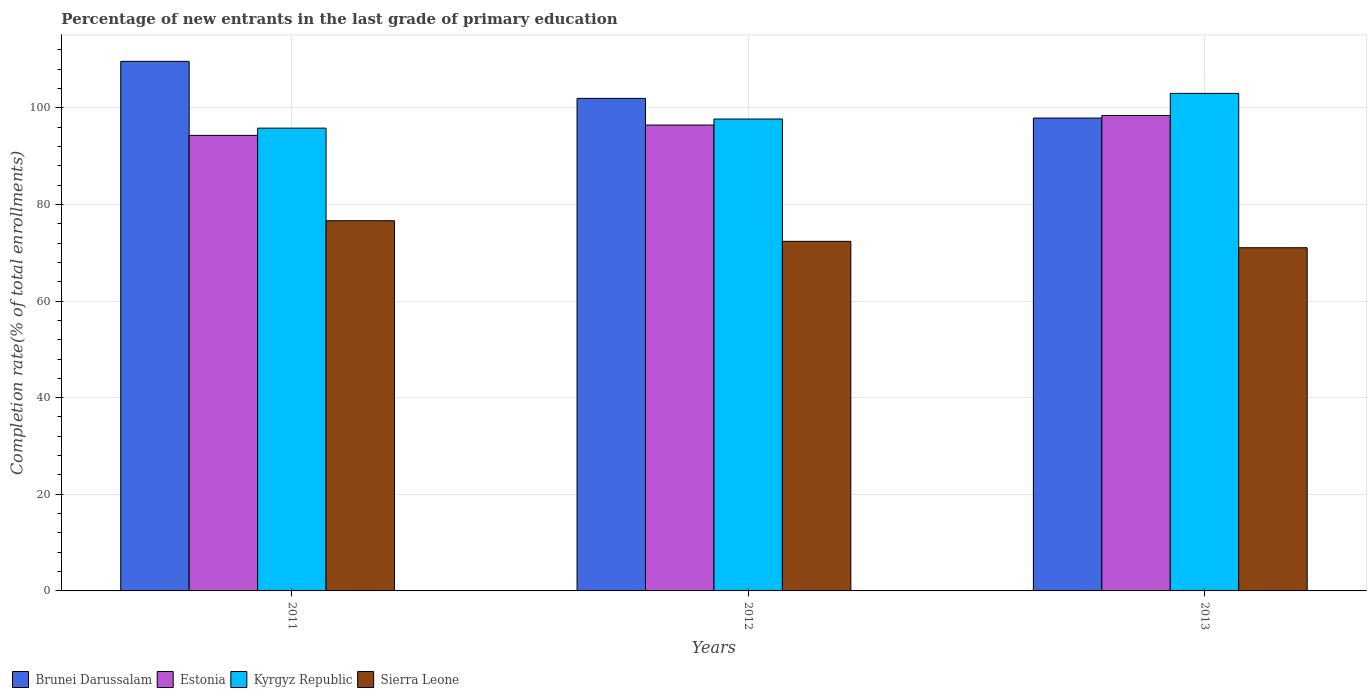Are the number of bars per tick equal to the number of legend labels?
Your answer should be very brief. Yes. Are the number of bars on each tick of the X-axis equal?
Make the answer very short. Yes. How many bars are there on the 2nd tick from the left?
Offer a very short reply. 4. What is the label of the 3rd group of bars from the left?
Your response must be concise. 2013. In how many cases, is the number of bars for a given year not equal to the number of legend labels?
Ensure brevity in your answer.  0. What is the percentage of new entrants in Kyrgyz Republic in 2011?
Give a very brief answer. 95.78. Across all years, what is the maximum percentage of new entrants in Sierra Leone?
Offer a very short reply. 76.62. Across all years, what is the minimum percentage of new entrants in Brunei Darussalam?
Offer a terse response. 97.87. In which year was the percentage of new entrants in Kyrgyz Republic maximum?
Offer a terse response. 2013. In which year was the percentage of new entrants in Sierra Leone minimum?
Offer a terse response. 2013. What is the total percentage of new entrants in Sierra Leone in the graph?
Offer a terse response. 220.01. What is the difference between the percentage of new entrants in Sierra Leone in 2012 and that in 2013?
Your response must be concise. 1.33. What is the difference between the percentage of new entrants in Sierra Leone in 2011 and the percentage of new entrants in Brunei Darussalam in 2012?
Your answer should be very brief. -25.32. What is the average percentage of new entrants in Estonia per year?
Your answer should be very brief. 96.37. In the year 2012, what is the difference between the percentage of new entrants in Estonia and percentage of new entrants in Kyrgyz Republic?
Provide a short and direct response. -1.25. What is the ratio of the percentage of new entrants in Estonia in 2012 to that in 2013?
Provide a short and direct response. 0.98. What is the difference between the highest and the second highest percentage of new entrants in Sierra Leone?
Offer a terse response. 4.27. What is the difference between the highest and the lowest percentage of new entrants in Brunei Darussalam?
Offer a terse response. 11.74. Is it the case that in every year, the sum of the percentage of new entrants in Brunei Darussalam and percentage of new entrants in Kyrgyz Republic is greater than the sum of percentage of new entrants in Estonia and percentage of new entrants in Sierra Leone?
Your answer should be compact. No. What does the 4th bar from the left in 2012 represents?
Provide a short and direct response. Sierra Leone. What does the 2nd bar from the right in 2011 represents?
Offer a terse response. Kyrgyz Republic. Is it the case that in every year, the sum of the percentage of new entrants in Estonia and percentage of new entrants in Brunei Darussalam is greater than the percentage of new entrants in Kyrgyz Republic?
Make the answer very short. Yes. Are all the bars in the graph horizontal?
Offer a very short reply. No. How are the legend labels stacked?
Your answer should be compact. Horizontal. What is the title of the graph?
Provide a succinct answer. Percentage of new entrants in the last grade of primary education. Does "Albania" appear as one of the legend labels in the graph?
Make the answer very short. No. What is the label or title of the X-axis?
Your answer should be very brief. Years. What is the label or title of the Y-axis?
Provide a short and direct response. Completion rate(% of total enrollments). What is the Completion rate(% of total enrollments) in Brunei Darussalam in 2011?
Your answer should be compact. 109.61. What is the Completion rate(% of total enrollments) in Estonia in 2011?
Give a very brief answer. 94.29. What is the Completion rate(% of total enrollments) of Kyrgyz Republic in 2011?
Ensure brevity in your answer.  95.78. What is the Completion rate(% of total enrollments) in Sierra Leone in 2011?
Your answer should be compact. 76.62. What is the Completion rate(% of total enrollments) in Brunei Darussalam in 2012?
Ensure brevity in your answer.  101.94. What is the Completion rate(% of total enrollments) in Estonia in 2012?
Give a very brief answer. 96.42. What is the Completion rate(% of total enrollments) in Kyrgyz Republic in 2012?
Provide a short and direct response. 97.67. What is the Completion rate(% of total enrollments) in Sierra Leone in 2012?
Make the answer very short. 72.36. What is the Completion rate(% of total enrollments) of Brunei Darussalam in 2013?
Offer a very short reply. 97.87. What is the Completion rate(% of total enrollments) in Estonia in 2013?
Your answer should be compact. 98.4. What is the Completion rate(% of total enrollments) in Kyrgyz Republic in 2013?
Give a very brief answer. 102.98. What is the Completion rate(% of total enrollments) in Sierra Leone in 2013?
Your response must be concise. 71.03. Across all years, what is the maximum Completion rate(% of total enrollments) in Brunei Darussalam?
Provide a short and direct response. 109.61. Across all years, what is the maximum Completion rate(% of total enrollments) of Estonia?
Your response must be concise. 98.4. Across all years, what is the maximum Completion rate(% of total enrollments) of Kyrgyz Republic?
Provide a short and direct response. 102.98. Across all years, what is the maximum Completion rate(% of total enrollments) in Sierra Leone?
Your response must be concise. 76.62. Across all years, what is the minimum Completion rate(% of total enrollments) in Brunei Darussalam?
Your answer should be very brief. 97.87. Across all years, what is the minimum Completion rate(% of total enrollments) in Estonia?
Make the answer very short. 94.29. Across all years, what is the minimum Completion rate(% of total enrollments) of Kyrgyz Republic?
Keep it short and to the point. 95.78. Across all years, what is the minimum Completion rate(% of total enrollments) in Sierra Leone?
Ensure brevity in your answer.  71.03. What is the total Completion rate(% of total enrollments) of Brunei Darussalam in the graph?
Offer a very short reply. 309.42. What is the total Completion rate(% of total enrollments) in Estonia in the graph?
Give a very brief answer. 289.1. What is the total Completion rate(% of total enrollments) in Kyrgyz Republic in the graph?
Your answer should be compact. 296.43. What is the total Completion rate(% of total enrollments) in Sierra Leone in the graph?
Provide a short and direct response. 220.01. What is the difference between the Completion rate(% of total enrollments) of Brunei Darussalam in 2011 and that in 2012?
Your response must be concise. 7.66. What is the difference between the Completion rate(% of total enrollments) of Estonia in 2011 and that in 2012?
Provide a short and direct response. -2.14. What is the difference between the Completion rate(% of total enrollments) in Kyrgyz Republic in 2011 and that in 2012?
Make the answer very short. -1.89. What is the difference between the Completion rate(% of total enrollments) of Sierra Leone in 2011 and that in 2012?
Provide a short and direct response. 4.27. What is the difference between the Completion rate(% of total enrollments) of Brunei Darussalam in 2011 and that in 2013?
Make the answer very short. 11.74. What is the difference between the Completion rate(% of total enrollments) in Estonia in 2011 and that in 2013?
Provide a short and direct response. -4.11. What is the difference between the Completion rate(% of total enrollments) of Kyrgyz Republic in 2011 and that in 2013?
Provide a succinct answer. -7.19. What is the difference between the Completion rate(% of total enrollments) of Sierra Leone in 2011 and that in 2013?
Offer a very short reply. 5.59. What is the difference between the Completion rate(% of total enrollments) in Brunei Darussalam in 2012 and that in 2013?
Your answer should be very brief. 4.07. What is the difference between the Completion rate(% of total enrollments) of Estonia in 2012 and that in 2013?
Give a very brief answer. -1.98. What is the difference between the Completion rate(% of total enrollments) of Kyrgyz Republic in 2012 and that in 2013?
Provide a short and direct response. -5.31. What is the difference between the Completion rate(% of total enrollments) of Sierra Leone in 2012 and that in 2013?
Provide a succinct answer. 1.33. What is the difference between the Completion rate(% of total enrollments) of Brunei Darussalam in 2011 and the Completion rate(% of total enrollments) of Estonia in 2012?
Provide a short and direct response. 13.19. What is the difference between the Completion rate(% of total enrollments) in Brunei Darussalam in 2011 and the Completion rate(% of total enrollments) in Kyrgyz Republic in 2012?
Provide a short and direct response. 11.94. What is the difference between the Completion rate(% of total enrollments) in Brunei Darussalam in 2011 and the Completion rate(% of total enrollments) in Sierra Leone in 2012?
Keep it short and to the point. 37.25. What is the difference between the Completion rate(% of total enrollments) in Estonia in 2011 and the Completion rate(% of total enrollments) in Kyrgyz Republic in 2012?
Ensure brevity in your answer.  -3.38. What is the difference between the Completion rate(% of total enrollments) in Estonia in 2011 and the Completion rate(% of total enrollments) in Sierra Leone in 2012?
Your answer should be very brief. 21.93. What is the difference between the Completion rate(% of total enrollments) of Kyrgyz Republic in 2011 and the Completion rate(% of total enrollments) of Sierra Leone in 2012?
Provide a short and direct response. 23.43. What is the difference between the Completion rate(% of total enrollments) in Brunei Darussalam in 2011 and the Completion rate(% of total enrollments) in Estonia in 2013?
Ensure brevity in your answer.  11.21. What is the difference between the Completion rate(% of total enrollments) in Brunei Darussalam in 2011 and the Completion rate(% of total enrollments) in Kyrgyz Republic in 2013?
Your answer should be compact. 6.63. What is the difference between the Completion rate(% of total enrollments) of Brunei Darussalam in 2011 and the Completion rate(% of total enrollments) of Sierra Leone in 2013?
Offer a very short reply. 38.58. What is the difference between the Completion rate(% of total enrollments) in Estonia in 2011 and the Completion rate(% of total enrollments) in Kyrgyz Republic in 2013?
Your response must be concise. -8.69. What is the difference between the Completion rate(% of total enrollments) of Estonia in 2011 and the Completion rate(% of total enrollments) of Sierra Leone in 2013?
Offer a very short reply. 23.26. What is the difference between the Completion rate(% of total enrollments) of Kyrgyz Republic in 2011 and the Completion rate(% of total enrollments) of Sierra Leone in 2013?
Keep it short and to the point. 24.75. What is the difference between the Completion rate(% of total enrollments) in Brunei Darussalam in 2012 and the Completion rate(% of total enrollments) in Estonia in 2013?
Your response must be concise. 3.55. What is the difference between the Completion rate(% of total enrollments) in Brunei Darussalam in 2012 and the Completion rate(% of total enrollments) in Kyrgyz Republic in 2013?
Give a very brief answer. -1.03. What is the difference between the Completion rate(% of total enrollments) in Brunei Darussalam in 2012 and the Completion rate(% of total enrollments) in Sierra Leone in 2013?
Your answer should be compact. 30.91. What is the difference between the Completion rate(% of total enrollments) of Estonia in 2012 and the Completion rate(% of total enrollments) of Kyrgyz Republic in 2013?
Make the answer very short. -6.56. What is the difference between the Completion rate(% of total enrollments) in Estonia in 2012 and the Completion rate(% of total enrollments) in Sierra Leone in 2013?
Provide a short and direct response. 25.39. What is the difference between the Completion rate(% of total enrollments) of Kyrgyz Republic in 2012 and the Completion rate(% of total enrollments) of Sierra Leone in 2013?
Give a very brief answer. 26.64. What is the average Completion rate(% of total enrollments) in Brunei Darussalam per year?
Keep it short and to the point. 103.14. What is the average Completion rate(% of total enrollments) in Estonia per year?
Ensure brevity in your answer.  96.37. What is the average Completion rate(% of total enrollments) of Kyrgyz Republic per year?
Offer a terse response. 98.81. What is the average Completion rate(% of total enrollments) of Sierra Leone per year?
Offer a very short reply. 73.34. In the year 2011, what is the difference between the Completion rate(% of total enrollments) in Brunei Darussalam and Completion rate(% of total enrollments) in Estonia?
Offer a terse response. 15.32. In the year 2011, what is the difference between the Completion rate(% of total enrollments) in Brunei Darussalam and Completion rate(% of total enrollments) in Kyrgyz Republic?
Give a very brief answer. 13.82. In the year 2011, what is the difference between the Completion rate(% of total enrollments) of Brunei Darussalam and Completion rate(% of total enrollments) of Sierra Leone?
Give a very brief answer. 32.99. In the year 2011, what is the difference between the Completion rate(% of total enrollments) in Estonia and Completion rate(% of total enrollments) in Kyrgyz Republic?
Ensure brevity in your answer.  -1.5. In the year 2011, what is the difference between the Completion rate(% of total enrollments) in Estonia and Completion rate(% of total enrollments) in Sierra Leone?
Make the answer very short. 17.66. In the year 2011, what is the difference between the Completion rate(% of total enrollments) in Kyrgyz Republic and Completion rate(% of total enrollments) in Sierra Leone?
Your answer should be very brief. 19.16. In the year 2012, what is the difference between the Completion rate(% of total enrollments) in Brunei Darussalam and Completion rate(% of total enrollments) in Estonia?
Keep it short and to the point. 5.52. In the year 2012, what is the difference between the Completion rate(% of total enrollments) of Brunei Darussalam and Completion rate(% of total enrollments) of Kyrgyz Republic?
Make the answer very short. 4.27. In the year 2012, what is the difference between the Completion rate(% of total enrollments) of Brunei Darussalam and Completion rate(% of total enrollments) of Sierra Leone?
Make the answer very short. 29.59. In the year 2012, what is the difference between the Completion rate(% of total enrollments) in Estonia and Completion rate(% of total enrollments) in Kyrgyz Republic?
Ensure brevity in your answer.  -1.25. In the year 2012, what is the difference between the Completion rate(% of total enrollments) in Estonia and Completion rate(% of total enrollments) in Sierra Leone?
Provide a short and direct response. 24.07. In the year 2012, what is the difference between the Completion rate(% of total enrollments) in Kyrgyz Republic and Completion rate(% of total enrollments) in Sierra Leone?
Provide a succinct answer. 25.31. In the year 2013, what is the difference between the Completion rate(% of total enrollments) of Brunei Darussalam and Completion rate(% of total enrollments) of Estonia?
Provide a short and direct response. -0.53. In the year 2013, what is the difference between the Completion rate(% of total enrollments) of Brunei Darussalam and Completion rate(% of total enrollments) of Kyrgyz Republic?
Make the answer very short. -5.11. In the year 2013, what is the difference between the Completion rate(% of total enrollments) in Brunei Darussalam and Completion rate(% of total enrollments) in Sierra Leone?
Offer a terse response. 26.84. In the year 2013, what is the difference between the Completion rate(% of total enrollments) in Estonia and Completion rate(% of total enrollments) in Kyrgyz Republic?
Keep it short and to the point. -4.58. In the year 2013, what is the difference between the Completion rate(% of total enrollments) of Estonia and Completion rate(% of total enrollments) of Sierra Leone?
Give a very brief answer. 27.37. In the year 2013, what is the difference between the Completion rate(% of total enrollments) in Kyrgyz Republic and Completion rate(% of total enrollments) in Sierra Leone?
Provide a succinct answer. 31.95. What is the ratio of the Completion rate(% of total enrollments) in Brunei Darussalam in 2011 to that in 2012?
Your response must be concise. 1.08. What is the ratio of the Completion rate(% of total enrollments) of Estonia in 2011 to that in 2012?
Offer a terse response. 0.98. What is the ratio of the Completion rate(% of total enrollments) of Kyrgyz Republic in 2011 to that in 2012?
Provide a succinct answer. 0.98. What is the ratio of the Completion rate(% of total enrollments) of Sierra Leone in 2011 to that in 2012?
Ensure brevity in your answer.  1.06. What is the ratio of the Completion rate(% of total enrollments) of Brunei Darussalam in 2011 to that in 2013?
Offer a terse response. 1.12. What is the ratio of the Completion rate(% of total enrollments) in Estonia in 2011 to that in 2013?
Give a very brief answer. 0.96. What is the ratio of the Completion rate(% of total enrollments) in Kyrgyz Republic in 2011 to that in 2013?
Your answer should be very brief. 0.93. What is the ratio of the Completion rate(% of total enrollments) in Sierra Leone in 2011 to that in 2013?
Provide a succinct answer. 1.08. What is the ratio of the Completion rate(% of total enrollments) of Brunei Darussalam in 2012 to that in 2013?
Offer a very short reply. 1.04. What is the ratio of the Completion rate(% of total enrollments) in Estonia in 2012 to that in 2013?
Your answer should be compact. 0.98. What is the ratio of the Completion rate(% of total enrollments) of Kyrgyz Republic in 2012 to that in 2013?
Make the answer very short. 0.95. What is the ratio of the Completion rate(% of total enrollments) of Sierra Leone in 2012 to that in 2013?
Your answer should be compact. 1.02. What is the difference between the highest and the second highest Completion rate(% of total enrollments) in Brunei Darussalam?
Give a very brief answer. 7.66. What is the difference between the highest and the second highest Completion rate(% of total enrollments) in Estonia?
Offer a terse response. 1.98. What is the difference between the highest and the second highest Completion rate(% of total enrollments) of Kyrgyz Republic?
Offer a very short reply. 5.31. What is the difference between the highest and the second highest Completion rate(% of total enrollments) in Sierra Leone?
Provide a succinct answer. 4.27. What is the difference between the highest and the lowest Completion rate(% of total enrollments) of Brunei Darussalam?
Give a very brief answer. 11.74. What is the difference between the highest and the lowest Completion rate(% of total enrollments) in Estonia?
Your response must be concise. 4.11. What is the difference between the highest and the lowest Completion rate(% of total enrollments) in Kyrgyz Republic?
Ensure brevity in your answer.  7.19. What is the difference between the highest and the lowest Completion rate(% of total enrollments) of Sierra Leone?
Your answer should be compact. 5.59. 